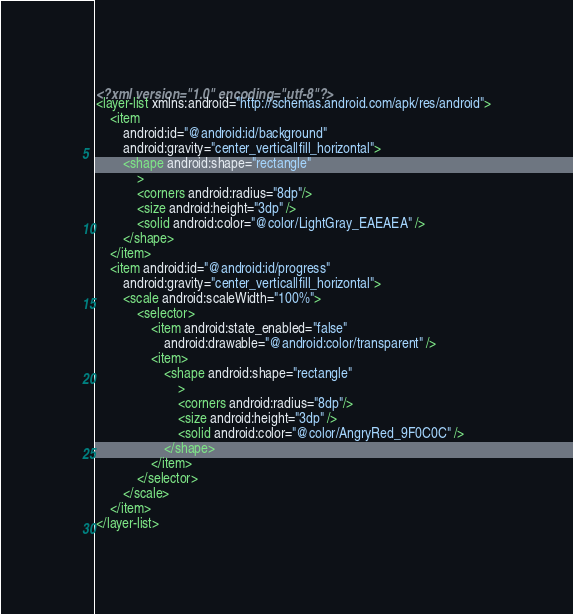<code> <loc_0><loc_0><loc_500><loc_500><_XML_><?xml version="1.0" encoding="utf-8"?>
<layer-list xmlns:android="http://schemas.android.com/apk/res/android">
    <item
        android:id="@android:id/background"
        android:gravity="center_vertical|fill_horizontal">
        <shape android:shape="rectangle"
            >
            <corners android:radius="8dp"/>
            <size android:height="3dp" />
            <solid android:color="@color/LightGray_EAEAEA" />
        </shape>
    </item>
    <item android:id="@android:id/progress"
        android:gravity="center_vertical|fill_horizontal">
        <scale android:scaleWidth="100%">
            <selector>
                <item android:state_enabled="false"
                    android:drawable="@android:color/transparent" />
                <item>
                    <shape android:shape="rectangle"
                        >
                        <corners android:radius="8dp"/>
                        <size android:height="3dp" />
                        <solid android:color="@color/AngryRed_9F0C0C" />
                    </shape>
                </item>
            </selector>
        </scale>
    </item>
</layer-list></code> 